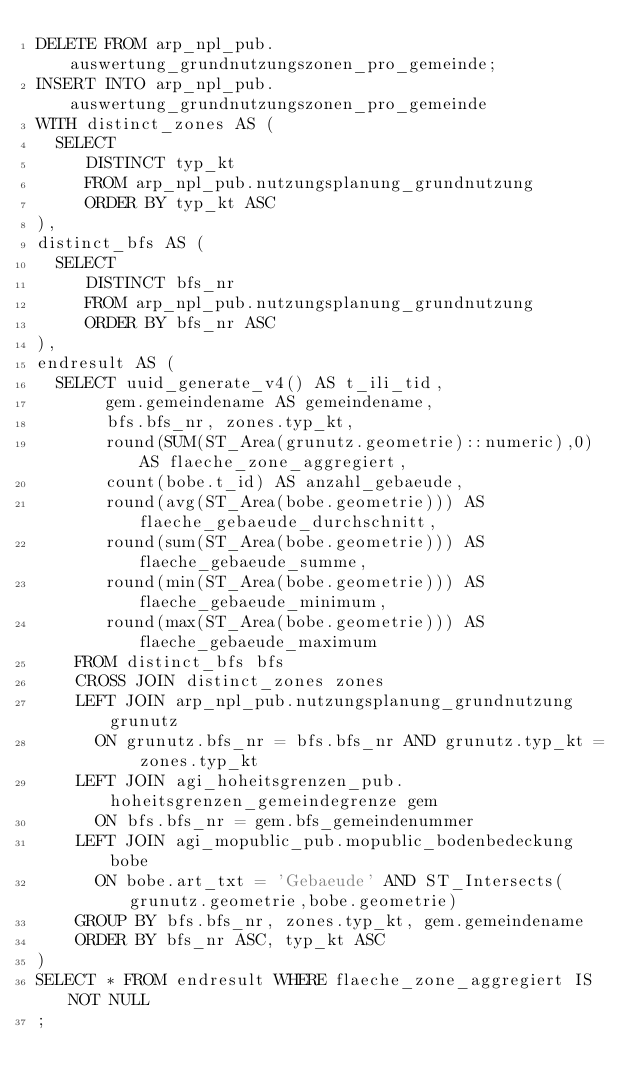<code> <loc_0><loc_0><loc_500><loc_500><_SQL_>DELETE FROM arp_npl_pub.auswertung_grundnutzungszonen_pro_gemeinde;
INSERT INTO arp_npl_pub.auswertung_grundnutzungszonen_pro_gemeinde
WITH distinct_zones AS (
  SELECT
     DISTINCT typ_kt
     FROM arp_npl_pub.nutzungsplanung_grundnutzung
     ORDER BY typ_kt ASC
),
distinct_bfs AS (
  SELECT
     DISTINCT bfs_nr
     FROM arp_npl_pub.nutzungsplanung_grundnutzung
     ORDER BY bfs_nr ASC
),
endresult AS (
  SELECT uuid_generate_v4() AS t_ili_tid,
       gem.gemeindename AS gemeindename,
       bfs.bfs_nr, zones.typ_kt,
       round(SUM(ST_Area(grunutz.geometrie)::numeric),0) AS flaeche_zone_aggregiert,
       count(bobe.t_id) AS anzahl_gebaeude,
       round(avg(ST_Area(bobe.geometrie))) AS flaeche_gebaeude_durchschnitt,
       round(sum(ST_Area(bobe.geometrie))) AS flaeche_gebaeude_summe,
       round(min(ST_Area(bobe.geometrie))) AS flaeche_gebaeude_minimum,
       round(max(ST_Area(bobe.geometrie))) AS flaeche_gebaeude_maximum
    FROM distinct_bfs bfs
    CROSS JOIN distinct_zones zones
    LEFT JOIN arp_npl_pub.nutzungsplanung_grundnutzung grunutz
      ON grunutz.bfs_nr = bfs.bfs_nr AND grunutz.typ_kt = zones.typ_kt
    LEFT JOIN agi_hoheitsgrenzen_pub.hoheitsgrenzen_gemeindegrenze gem
      ON bfs.bfs_nr = gem.bfs_gemeindenummer
    LEFT JOIN agi_mopublic_pub.mopublic_bodenbedeckung bobe
      ON bobe.art_txt = 'Gebaeude' AND ST_Intersects(grunutz.geometrie,bobe.geometrie)
    GROUP BY bfs.bfs_nr, zones.typ_kt, gem.gemeindename
    ORDER BY bfs_nr ASC, typ_kt ASC
)
SELECT * FROM endresult WHERE flaeche_zone_aggregiert IS NOT NULL
;
</code> 